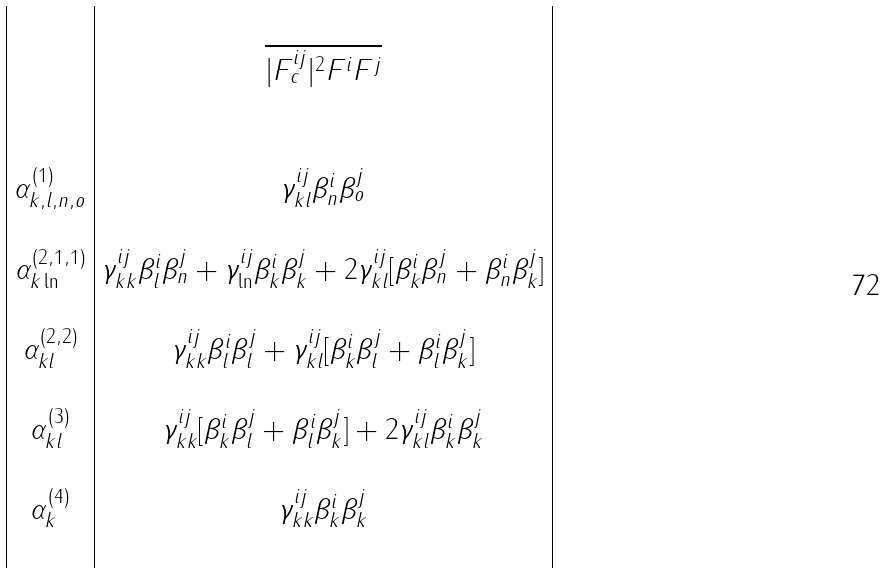Convert formula to latex. <formula><loc_0><loc_0><loc_500><loc_500>\begin{array} { | c | c | } & \\ & \overline { | F _ { c } ^ { i j } | ^ { 2 } F ^ { i } F ^ { j } } \\ & \\ & \\ \alpha _ { k , l , n , o } ^ { ( 1 ) } & \gamma _ { k l } ^ { i j } \beta ^ { i } _ { n } \beta ^ { j } _ { o } \\ & \\ \alpha _ { k \ln } ^ { ( 2 , 1 , 1 ) } & \gamma _ { k k } ^ { i j } \beta ^ { i } _ { l } \beta ^ { j } _ { n } + \gamma _ { \ln } ^ { i j } \beta ^ { i } _ { k } \beta ^ { j } _ { k } + 2 \gamma _ { k l } ^ { i j } [ \beta ^ { i } _ { k } \beta ^ { j } _ { n } + \beta ^ { i } _ { n } \beta ^ { j } _ { k } ] \\ & \\ \alpha _ { k l } ^ { ( 2 , 2 ) } & \gamma _ { k k } ^ { i j } \beta ^ { i } _ { l } \beta ^ { j } _ { l } + \gamma _ { k l } ^ { i j } [ \beta ^ { i } _ { k } \beta ^ { j } _ { l } + \beta ^ { i } _ { l } \beta ^ { j } _ { k } ] \\ & \\ \alpha _ { k l } ^ { ( 3 ) } & \gamma _ { k k } ^ { i j } [ \beta ^ { i } _ { k } \beta ^ { j } _ { l } + \beta ^ { i } _ { l } \beta ^ { j } _ { k } ] + 2 \gamma _ { k l } ^ { i j } \beta ^ { i } _ { k } \beta ^ { j } _ { k } \\ & \\ \alpha _ { k } ^ { ( 4 ) } & \gamma _ { k k } ^ { i j } \beta ^ { i } _ { k } \beta ^ { j } _ { k } \\ & \\ \end{array}</formula> 